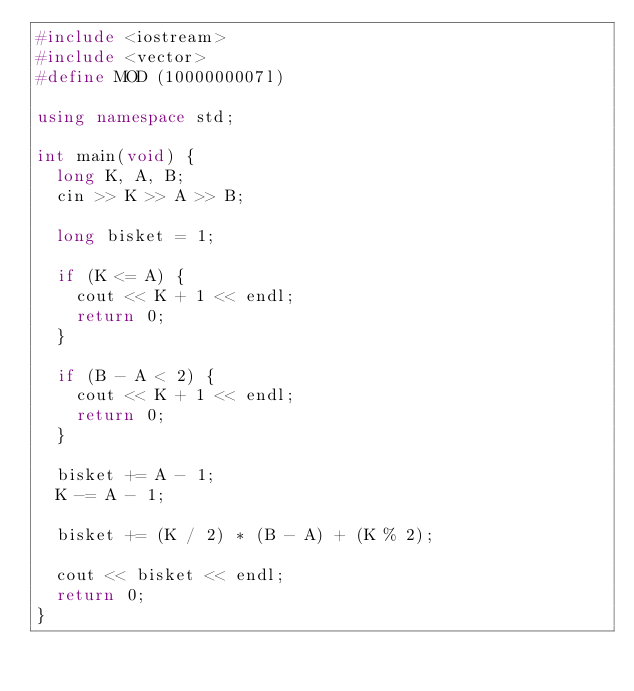<code> <loc_0><loc_0><loc_500><loc_500><_C++_>#include <iostream>
#include <vector>
#define MOD (1000000007l)

using namespace std;

int main(void) {
  long K, A, B;
  cin >> K >> A >> B;

  long bisket = 1;

  if (K <= A) {
    cout << K + 1 << endl;
    return 0;
  }

  if (B - A < 2) {
    cout << K + 1 << endl;
    return 0;
  }

  bisket += A - 1;
  K -= A - 1;

  bisket += (K / 2) * (B - A) + (K % 2);

  cout << bisket << endl;
  return 0;
}
</code> 